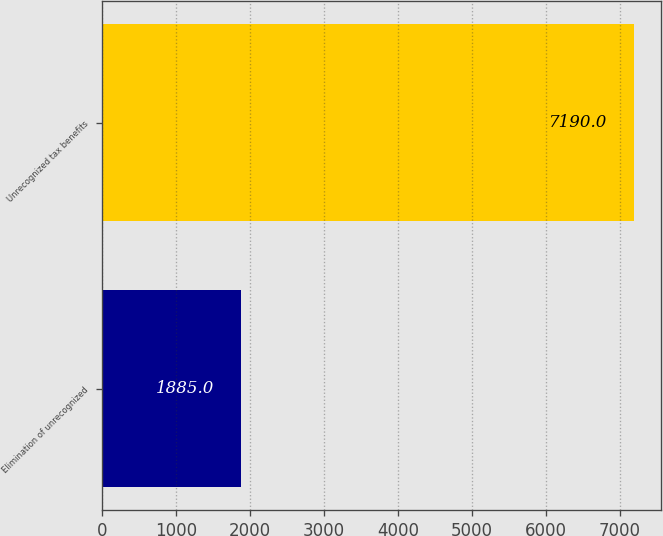<chart> <loc_0><loc_0><loc_500><loc_500><bar_chart><fcel>Elimination of unrecognized<fcel>Unrecognized tax benefits<nl><fcel>1885<fcel>7190<nl></chart> 